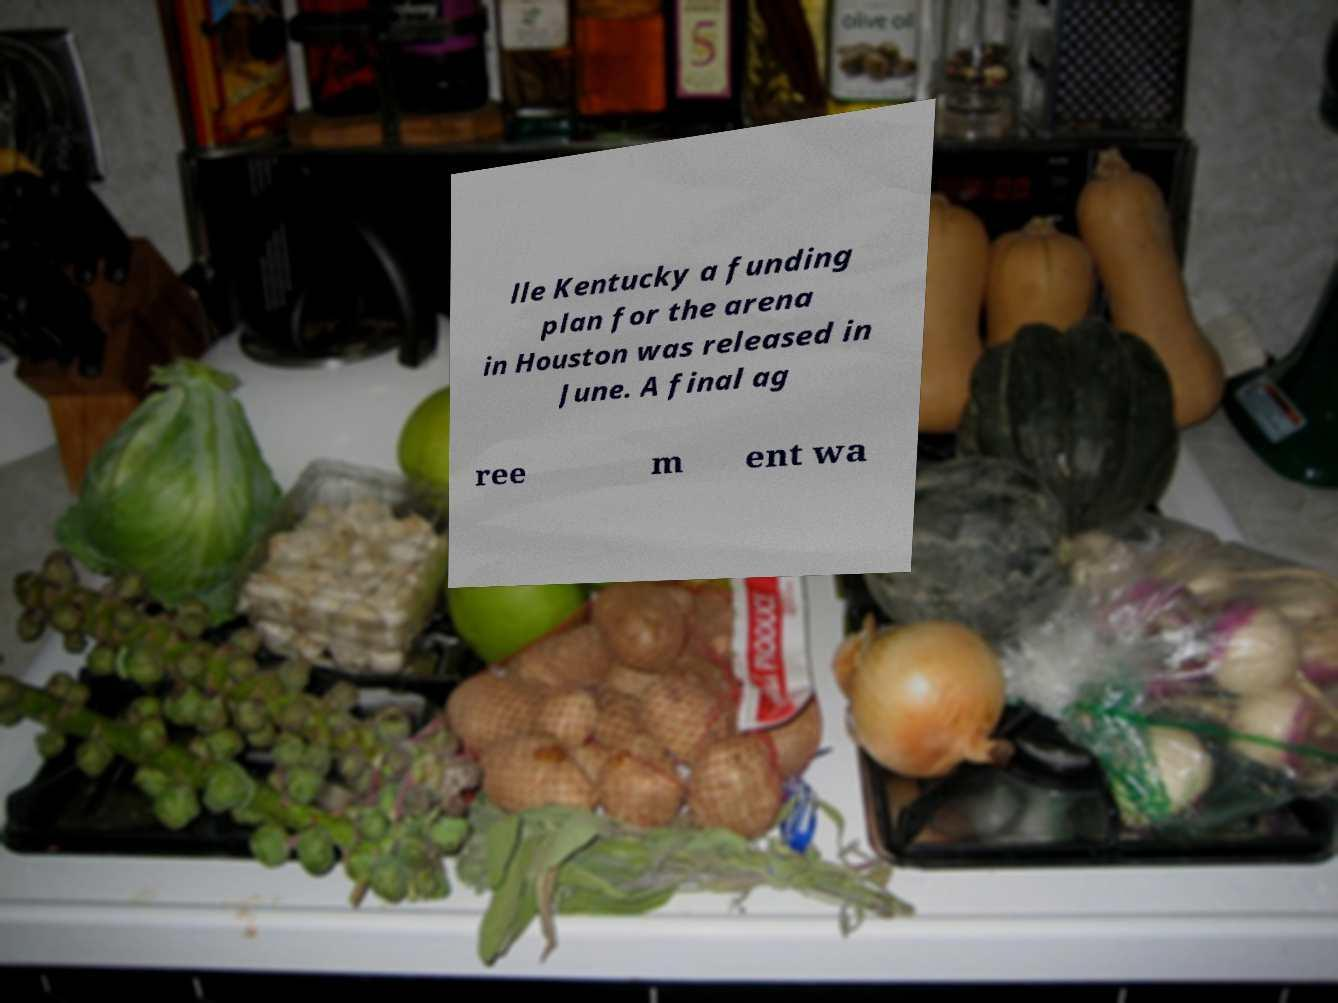For documentation purposes, I need the text within this image transcribed. Could you provide that? lle Kentucky a funding plan for the arena in Houston was released in June. A final ag ree m ent wa 